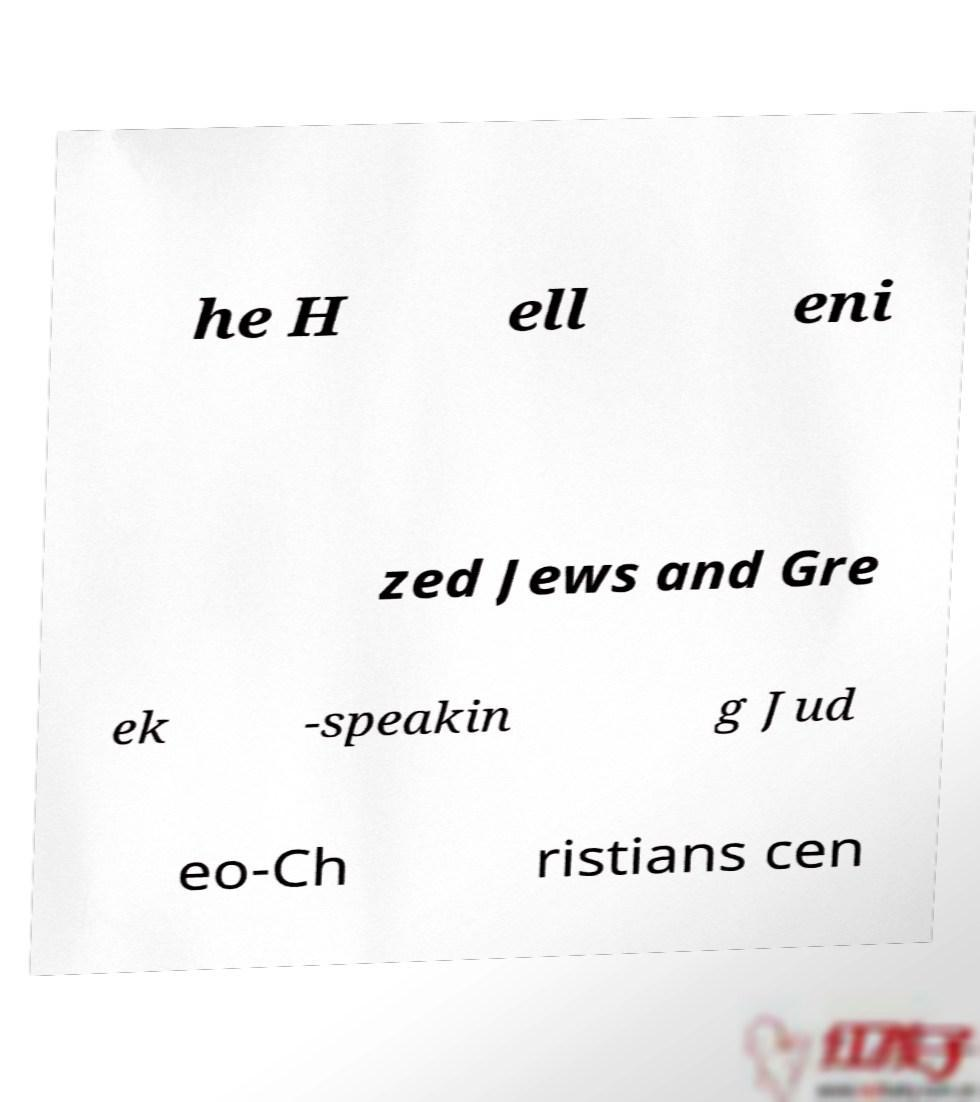What messages or text are displayed in this image? I need them in a readable, typed format. he H ell eni zed Jews and Gre ek -speakin g Jud eo-Ch ristians cen 